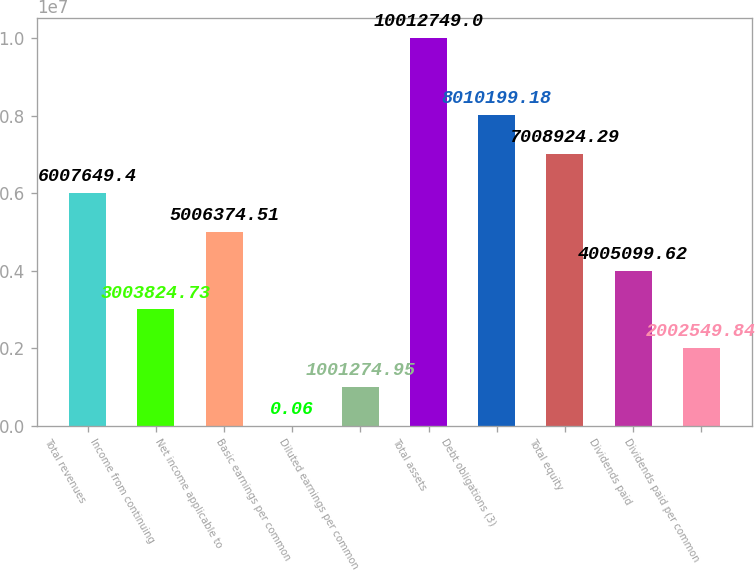<chart> <loc_0><loc_0><loc_500><loc_500><bar_chart><fcel>Total revenues<fcel>Income from continuing<fcel>Net income applicable to<fcel>Basic earnings per common<fcel>Diluted earnings per common<fcel>Total assets<fcel>Debt obligations (3)<fcel>Total equity<fcel>Dividends paid<fcel>Dividends paid per common<nl><fcel>6.00765e+06<fcel>3.00382e+06<fcel>5.00637e+06<fcel>0.06<fcel>1.00127e+06<fcel>1.00127e+07<fcel>8.0102e+06<fcel>7.00892e+06<fcel>4.0051e+06<fcel>2.00255e+06<nl></chart> 